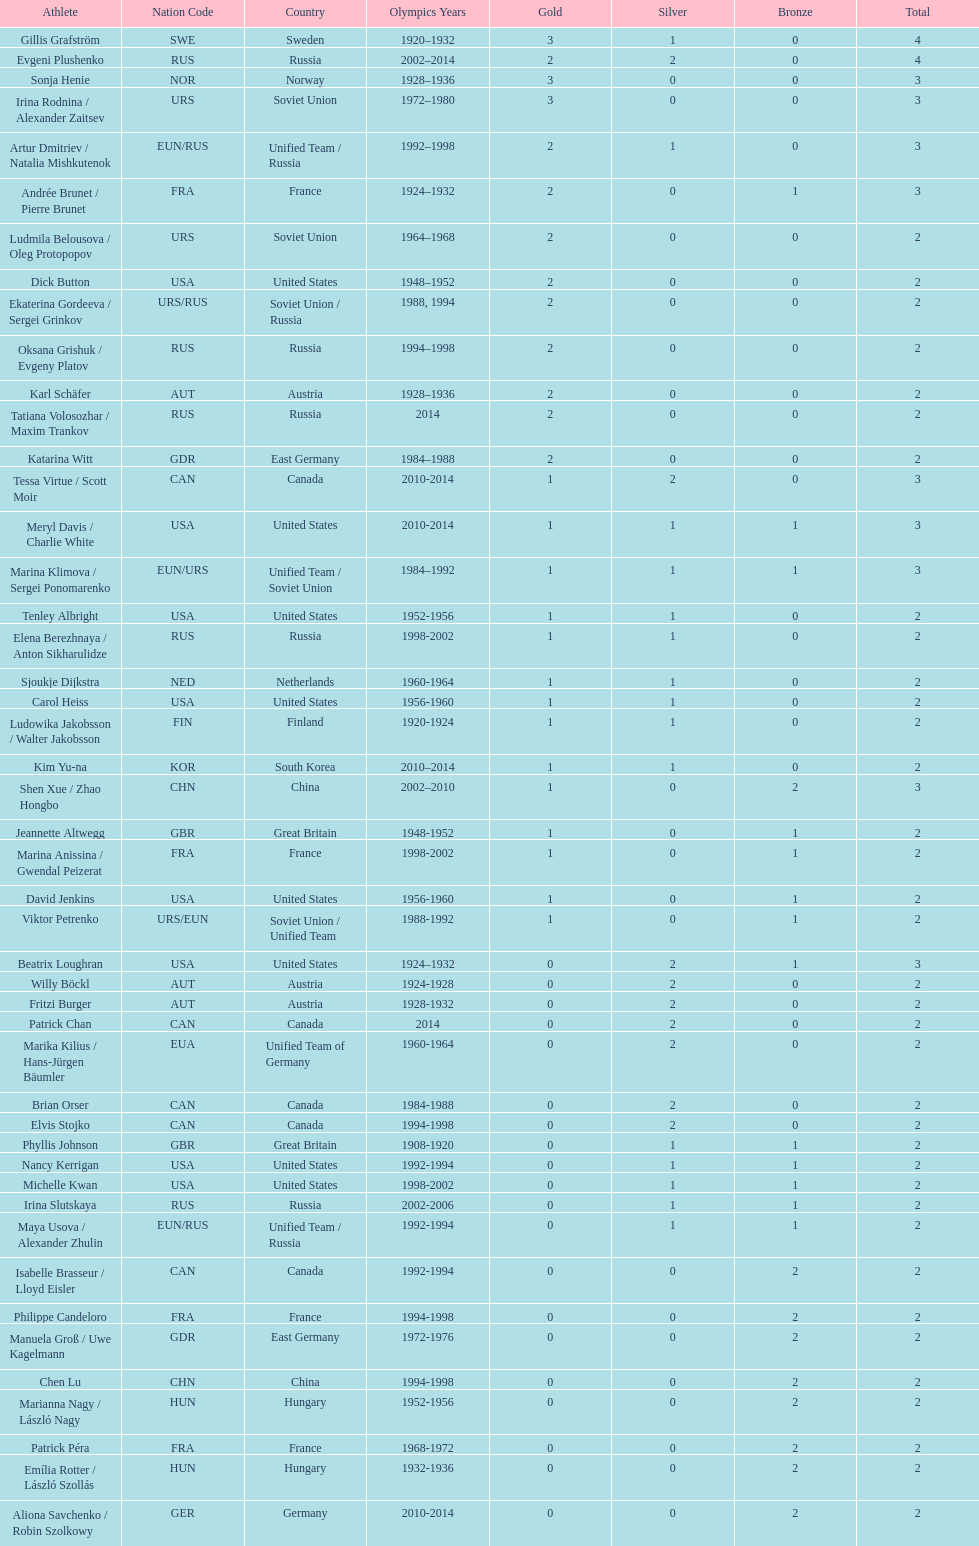How many silver medals did evgeni plushenko get? 2. 